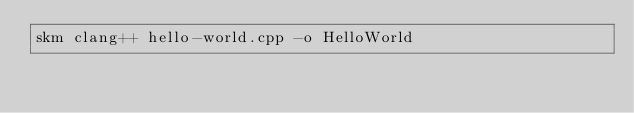<code> <loc_0><loc_0><loc_500><loc_500><_Bash_>skm clang++ hello-world.cpp -o HelloWorld</code> 